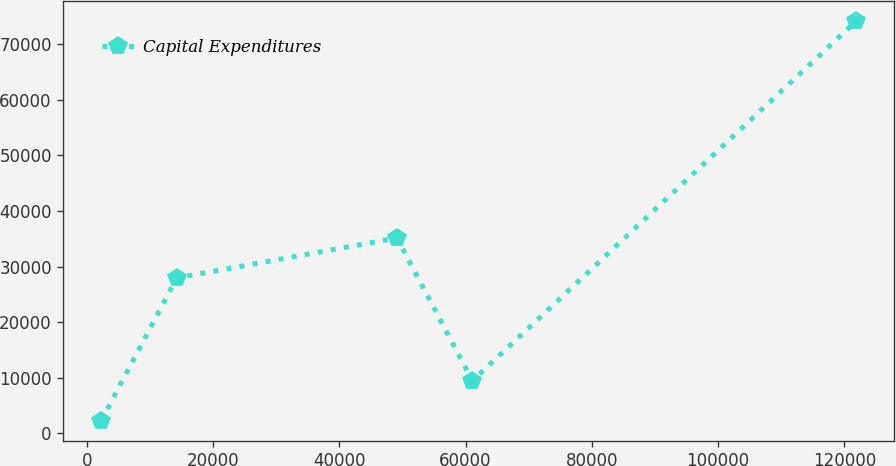Convert chart. <chart><loc_0><loc_0><loc_500><loc_500><line_chart><ecel><fcel>Capital Expenditures<nl><fcel>2295.75<fcel>2234.61<nl><fcel>14252<fcel>27943.7<nl><fcel>49121.2<fcel>35144.2<nl><fcel>61077.4<fcel>9435.12<nl><fcel>121858<fcel>74239.7<nl></chart> 